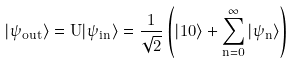<formula> <loc_0><loc_0><loc_500><loc_500>| \psi _ { o u t } \rangle = \hat { U } | \psi _ { i n } \rangle = \frac { 1 } { \sqrt { 2 } } \left ( | 1 0 \rangle + \sum _ { n = 0 } ^ { \infty } | \psi _ { n } \rangle \right )</formula> 